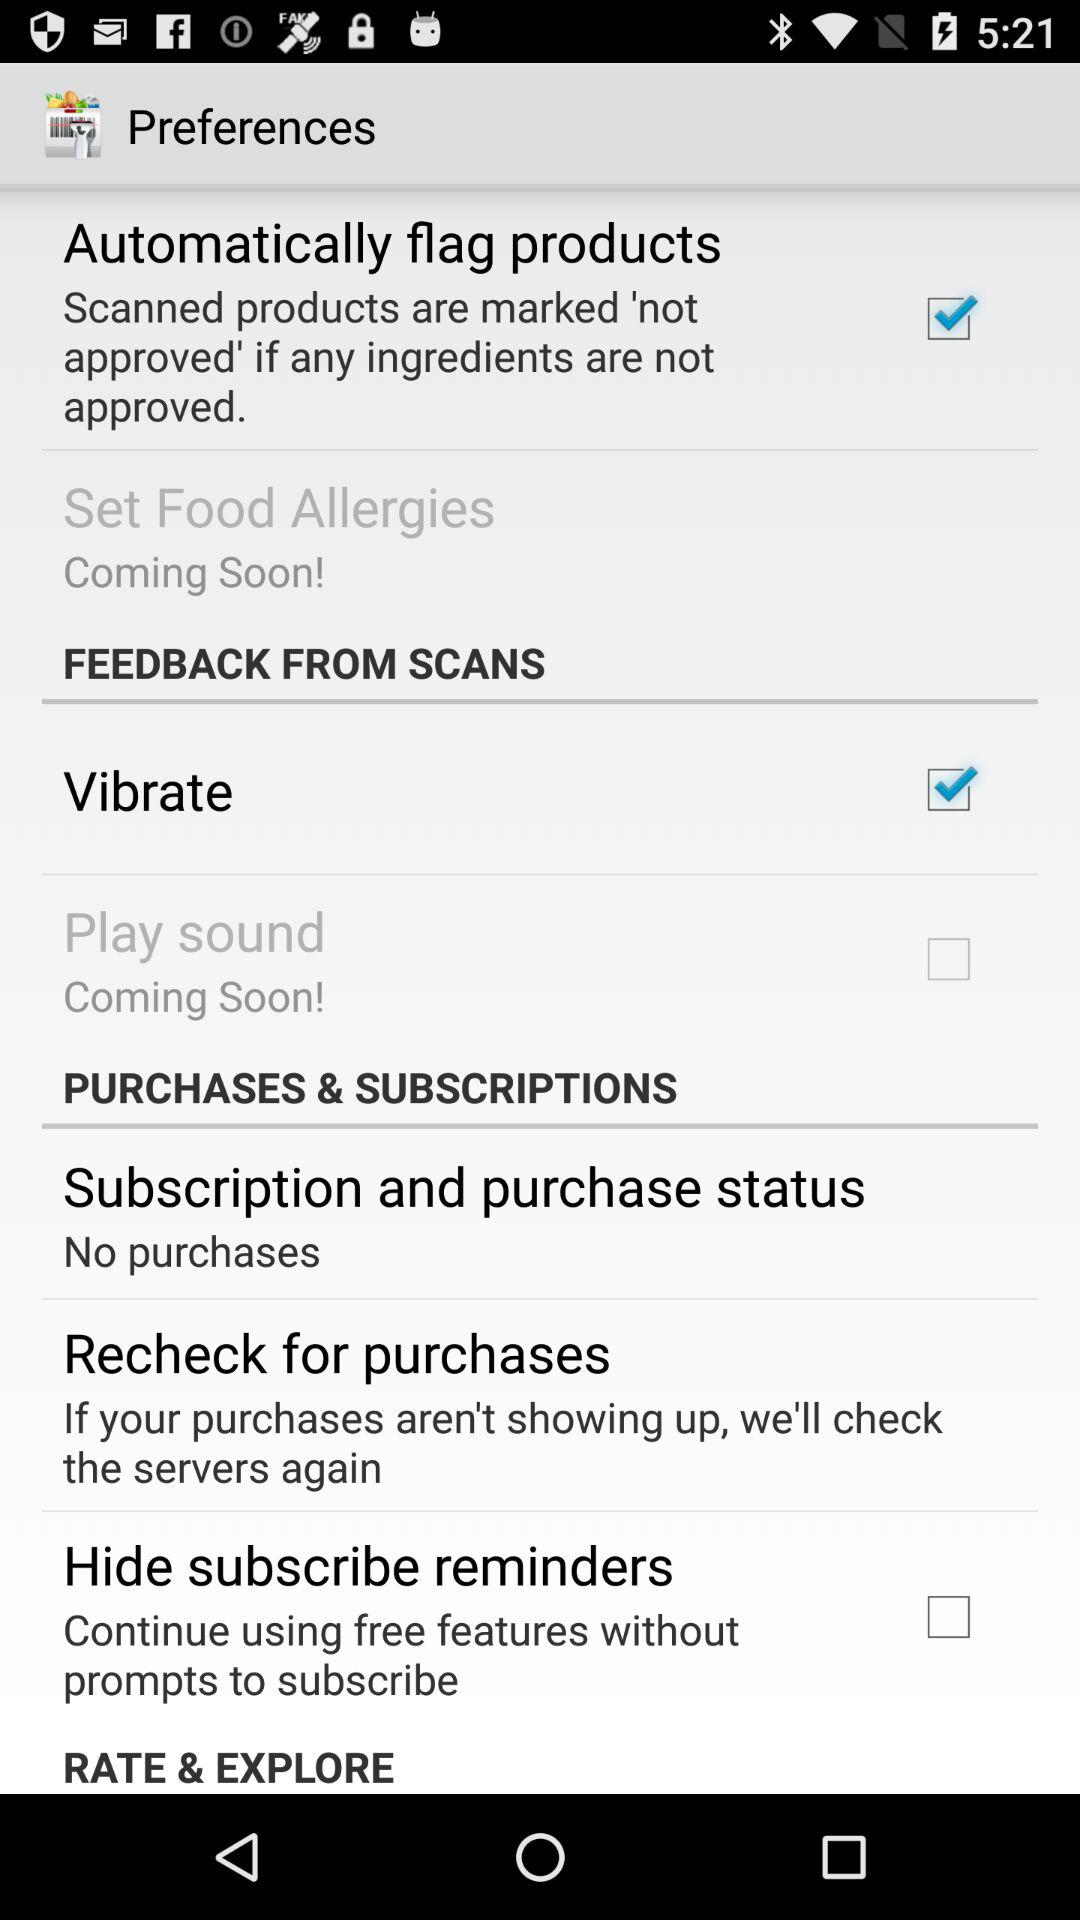What is the status of "Hide subscribe reminders"? The status of "Hide subscribe reminders" is "off". 